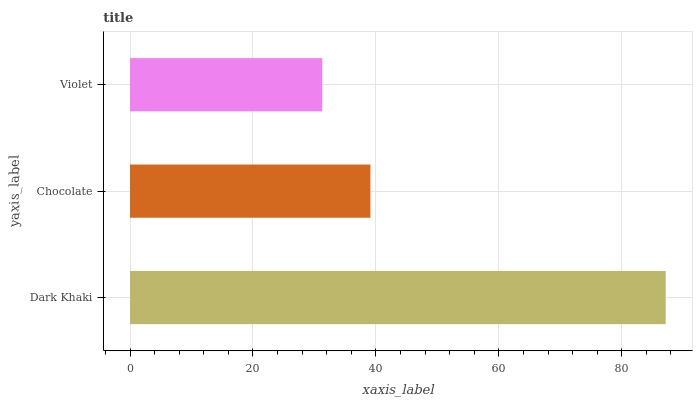Is Violet the minimum?
Answer yes or no. Yes. Is Dark Khaki the maximum?
Answer yes or no. Yes. Is Chocolate the minimum?
Answer yes or no. No. Is Chocolate the maximum?
Answer yes or no. No. Is Dark Khaki greater than Chocolate?
Answer yes or no. Yes. Is Chocolate less than Dark Khaki?
Answer yes or no. Yes. Is Chocolate greater than Dark Khaki?
Answer yes or no. No. Is Dark Khaki less than Chocolate?
Answer yes or no. No. Is Chocolate the high median?
Answer yes or no. Yes. Is Chocolate the low median?
Answer yes or no. Yes. Is Dark Khaki the high median?
Answer yes or no. No. Is Dark Khaki the low median?
Answer yes or no. No. 